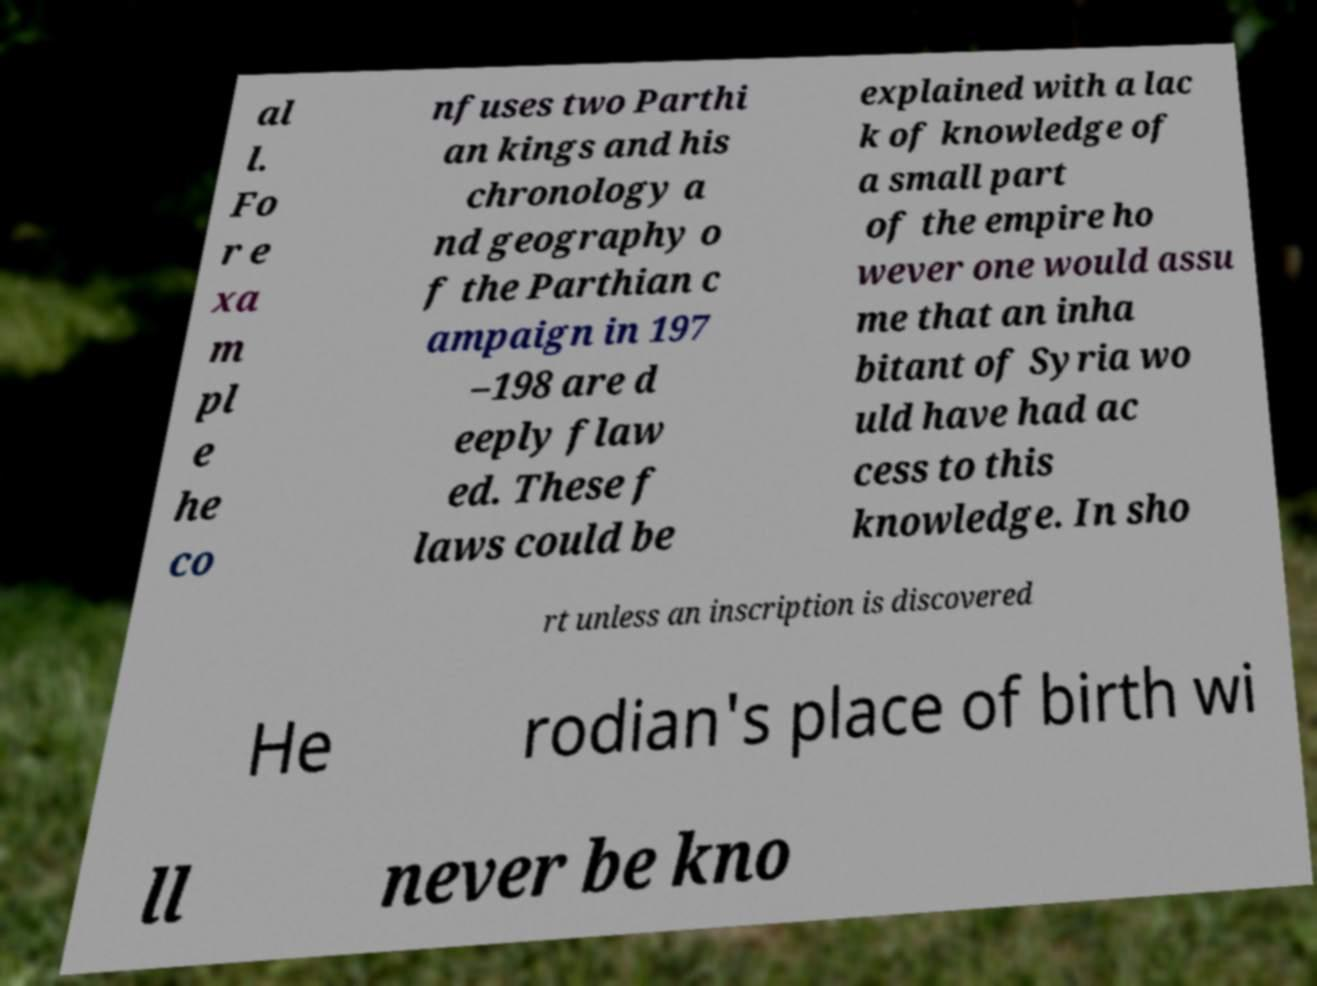Could you assist in decoding the text presented in this image and type it out clearly? al l. Fo r e xa m pl e he co nfuses two Parthi an kings and his chronology a nd geography o f the Parthian c ampaign in 197 –198 are d eeply flaw ed. These f laws could be explained with a lac k of knowledge of a small part of the empire ho wever one would assu me that an inha bitant of Syria wo uld have had ac cess to this knowledge. In sho rt unless an inscription is discovered He rodian's place of birth wi ll never be kno 